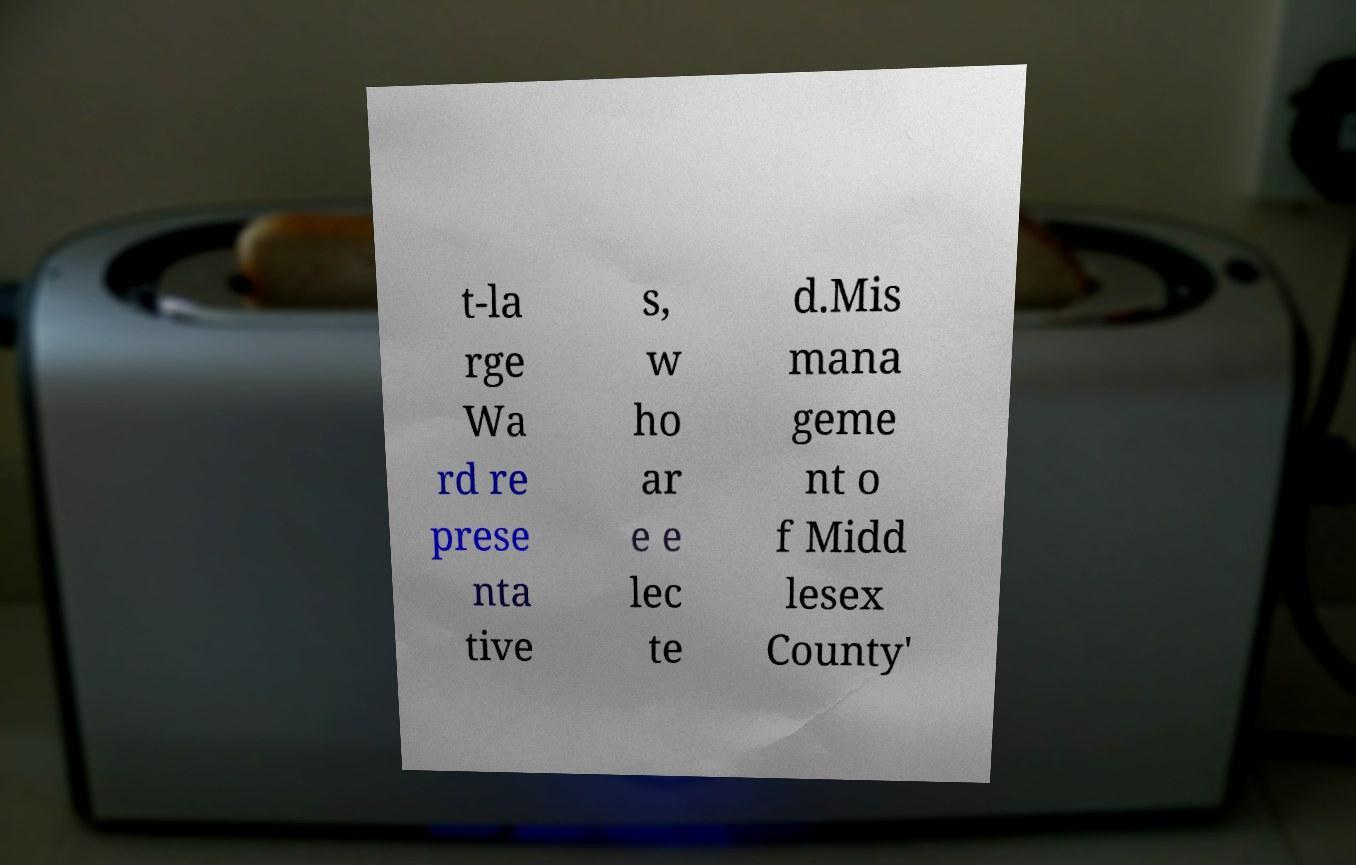Please read and relay the text visible in this image. What does it say? t-la rge Wa rd re prese nta tive s, w ho ar e e lec te d.Mis mana geme nt o f Midd lesex County' 